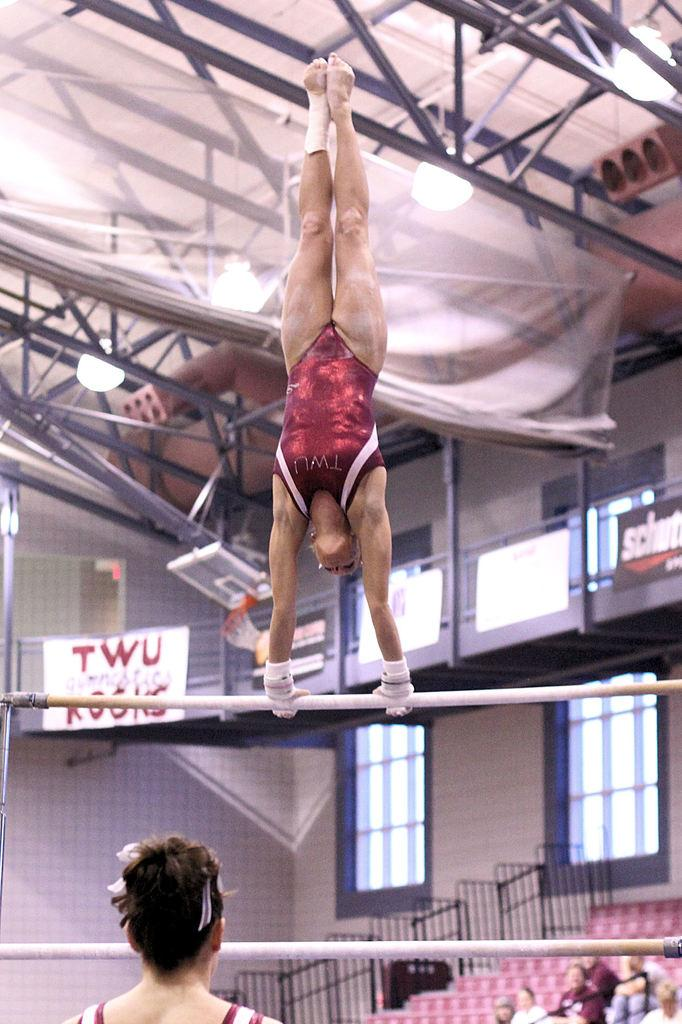<image>
Provide a brief description of the given image. One of the gymnists probably goes to the school TWU. 